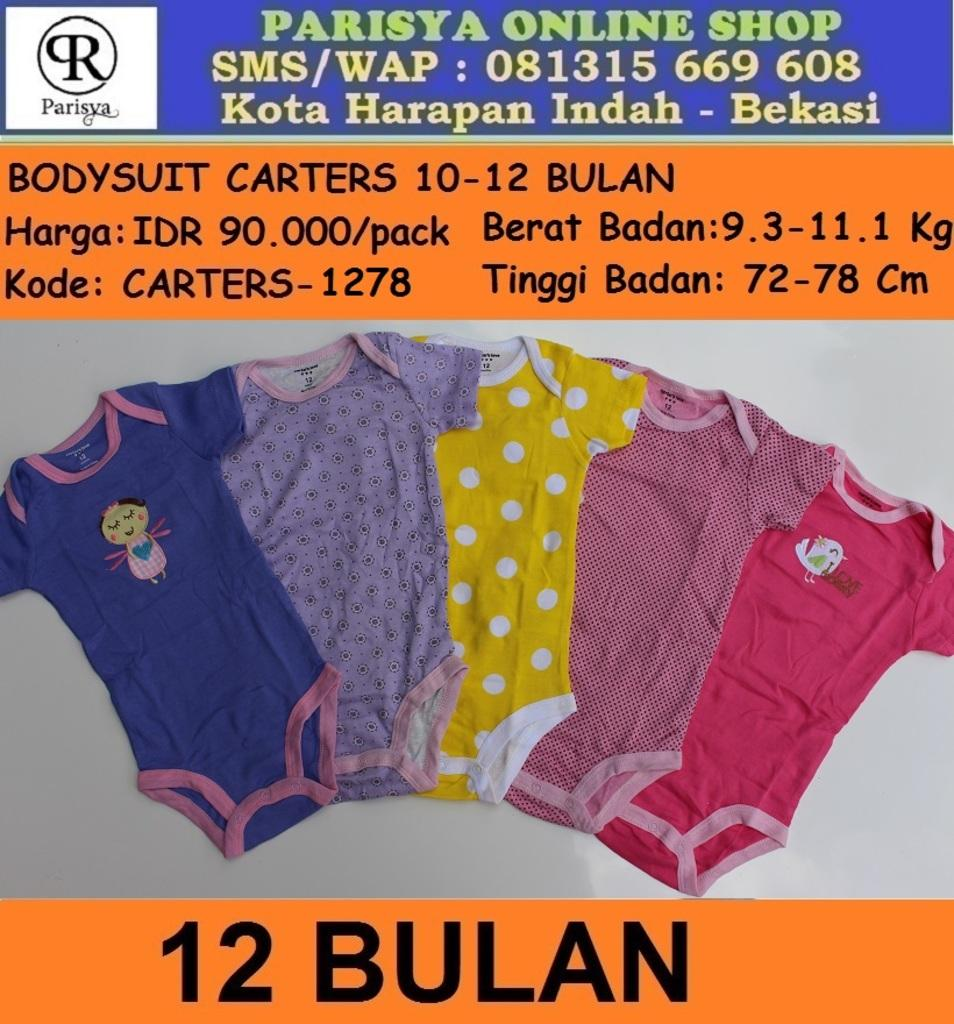What is featured on the poster in the image? There is a poster with text in the image. What else can be seen in the image besides the poster? There are clothes on a surface in the image. How does the kitty contribute to the team in the image? There is no kitty present in the image, so it cannot contribute to any team. 